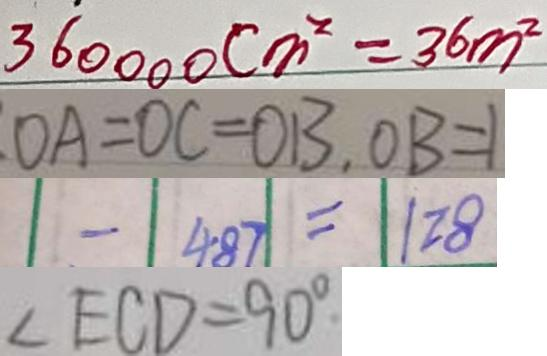Convert formula to latex. <formula><loc_0><loc_0><loc_500><loc_500>3 6 0 0 0 0 c m ^ { 2 } = 3 6 m ^ { 2 } 
 O A = O C = O B , O B = 1 
 - 4 8 7 = 1 2 8 
 \angle E C D = 9 0 ^ { \circ }</formula> 